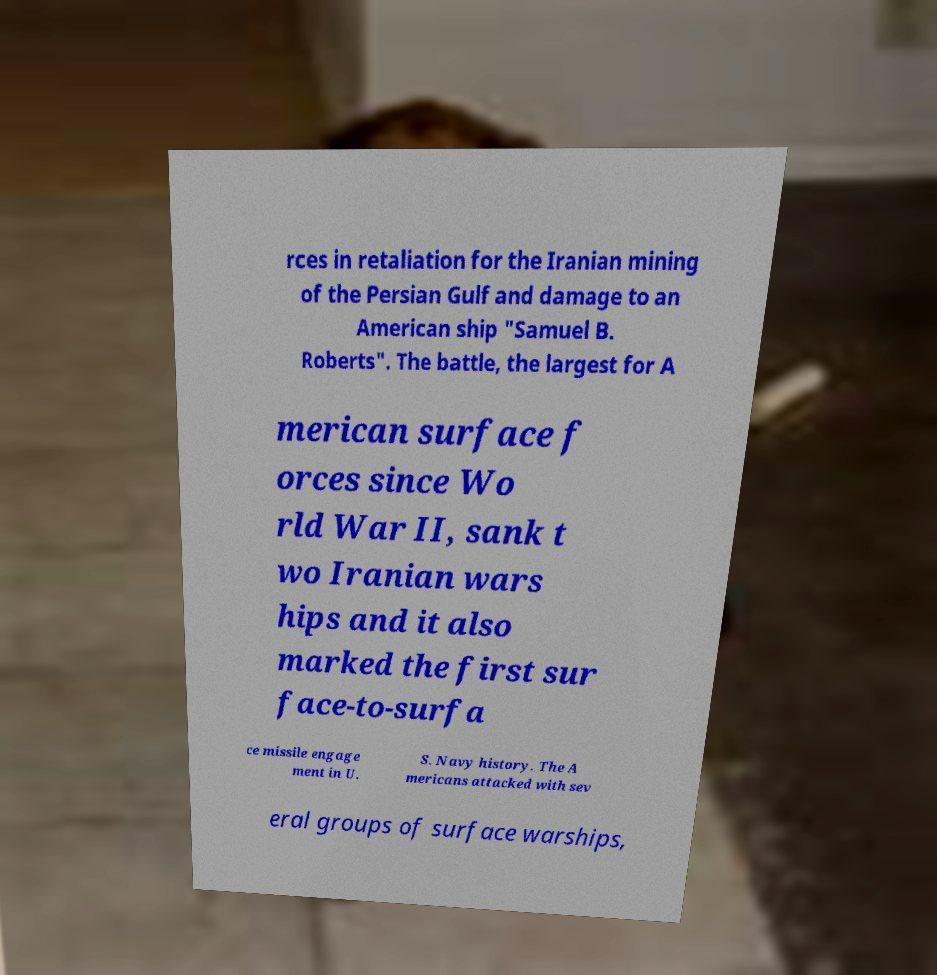Please identify and transcribe the text found in this image. rces in retaliation for the Iranian mining of the Persian Gulf and damage to an American ship "Samuel B. Roberts". The battle, the largest for A merican surface f orces since Wo rld War II, sank t wo Iranian wars hips and it also marked the first sur face-to-surfa ce missile engage ment in U. S. Navy history. The A mericans attacked with sev eral groups of surface warships, 